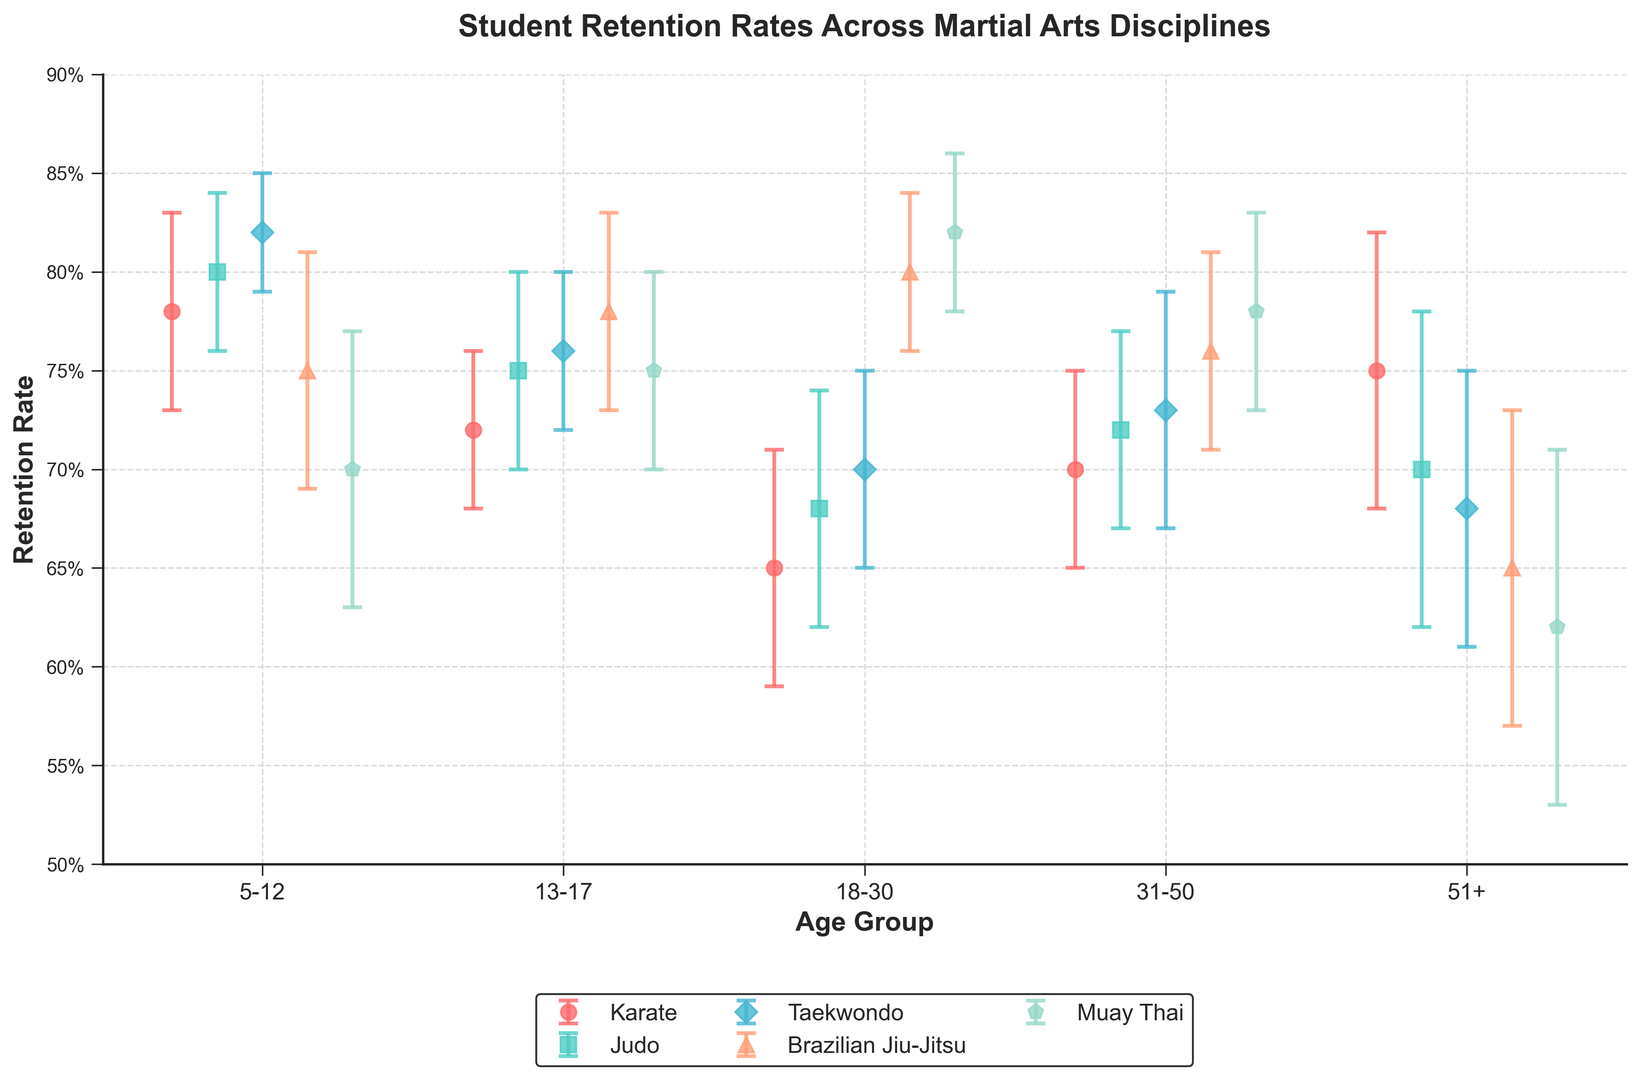What is the retention rate for Taekwondo in the 13-17 age group? To find the answer, look at Taekwondo's data in the 13-17 age group. The retention rate is plotted as a marker on the corresponding position on the x-axis (13-17).
Answer: 76% Which martial art has the highest retention rate for the 18-30 age group? Observe the data points for all martial arts in the 18-30 age group. The highest retention rate is represented by the marker placed at the highest y-value. Muay Thai has the highest rate for this age group.
Answer: Muay Thai What is the difference in retention rates between Judo and Brazilian Jiu-Jitsu for the 31-50 age group? Look at the retention rates of Judo and Brazilian Jiu-Jitsu for the 31-50 age group on the graph. Judo's retention rate is 72% and Brazilian Jiu-Jitsu's retention rate is 76%. The difference is 76% - 72%.
Answer: 4% For which age group does Karate have the lowest retention rate? Identify Karate's data points across all age groups. The lowest retention rate corresponds to the marker at the lowest y-value. Karate has the lowest retention rate in the 18-30 age group.
Answer: 18-30 How does the retention rate for Brazilian Jiu-Jitsu in the 51+ age group compare to Muay Thai in the same age group? Compare the markers for Brazilian Jiu-Jitsu and Muay Thai in the 51+ age group. Brazilian Jiu-Jitsu has a retention rate of 65%, while Muay Thai has a retention rate of 62%.
Answer: Brazilian Jiu-Jitsu has a higher retention rate Which martial art shows the most significant drop in retention rate from the 5-12 age group to the 51+ age group? Calculate the retention rate drop for each martial art between the 5-12 and 51+ age groups. Compare the differences: Karate (3%), Judo (10%), Taekwondo (14%), Brazilian Jiu-Jitsu (10%), and Muay Thai (8%). Taekwondo has the most significant drop.
Answer: Taekwondo What's the average retention rate for the 31-50 age group across all martial arts? Add the retention rates of all martial arts for the 31-50 age group and divide by the number of martial arts (5): (70% + 72% + 73% + 76% + 78%) / 5.
Answer: 73.8% Which age group has the smallest error margin for retention rates across all martial arts? Compare the error bars for all age groups across different martial arts. The 5-12 age group shows the smallest error margins overall.
Answer: 5-12 By how much does the retention rate of Judo in the 18-30 age group differ from that in the 5-12 age group? Locate Judo's retention rates for ages 18-30 and 5-12: 68% and 80% respectively. The difference is 80% - 68%.
Answer: 12% What color is used to represent Muay Thai on the plot? Identify the color associated with the markers for Muay Thai. The color representing Muay Thai is blue.
Answer: Blue 